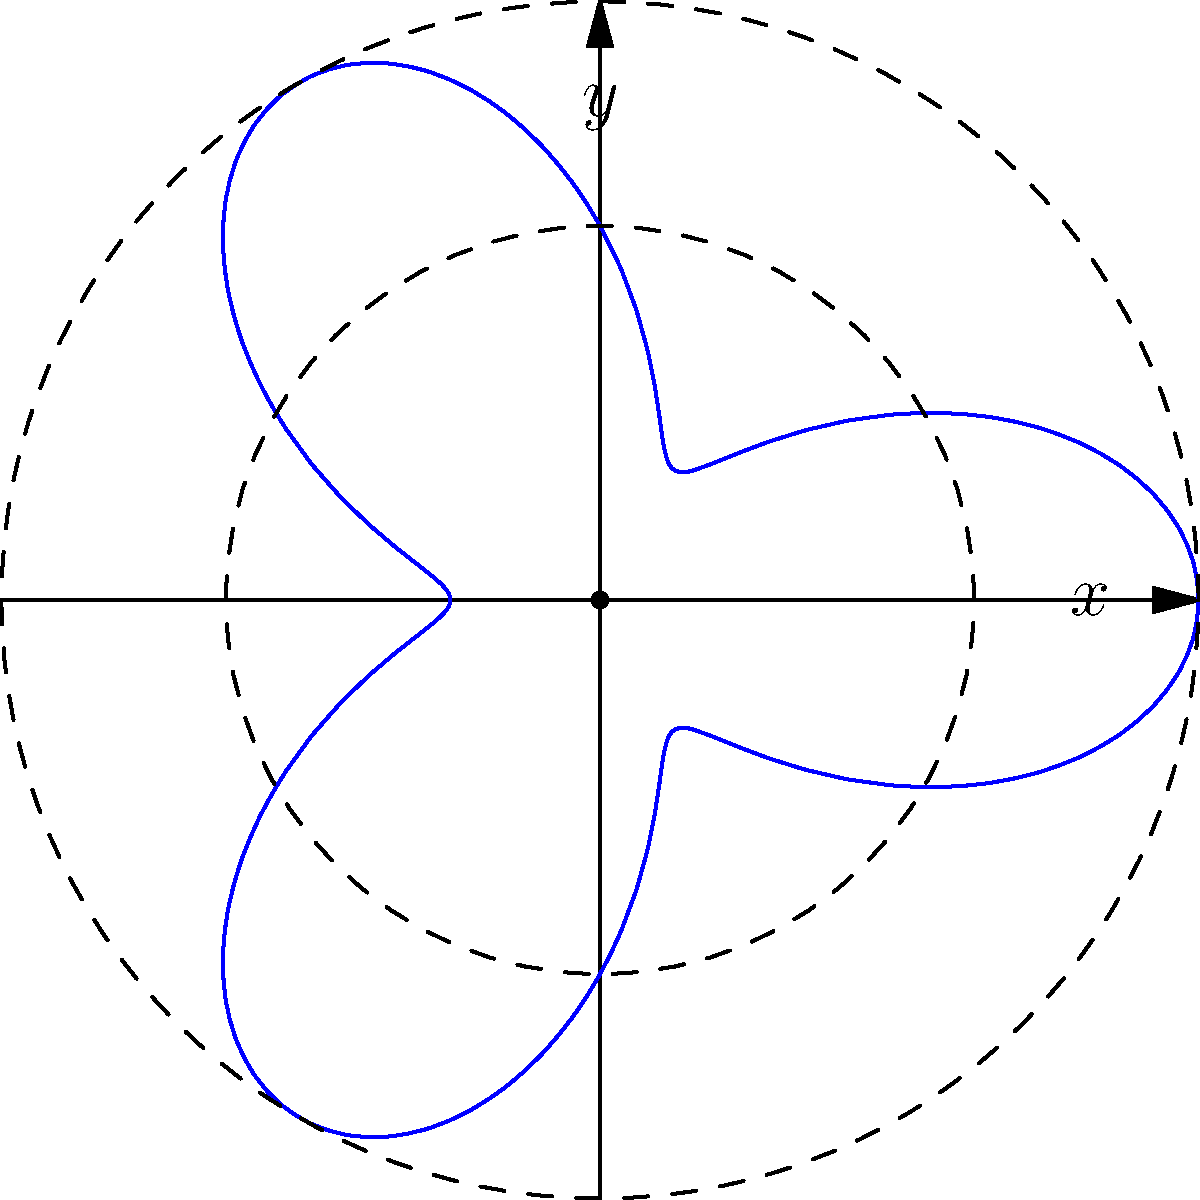As a private investigator, you're testing a new GPS tracking device. The device's range is represented by the polar equation $r = 5 + 3\cos(3\theta)$, where $r$ is in kilometers. What is the maximum range of the device? To find the maximum range of the GPS tracking device, we need to determine the maximum value of $r$ in the given polar equation:

1) The equation is $r = 5 + 3\cos(3\theta)$

2) The maximum value of cosine is 1, which occurs when its argument is a multiple of $2\pi$.

3) When $\cos(3\theta) = 1$, the equation becomes:
   $r_{max} = 5 + 3(1) = 5 + 3 = 8$

4) The minimum value of cosine is -1, which would give:
   $r_{min} = 5 + 3(-1) = 5 - 3 = 2$

5) The graph shows the curve oscillating between the circles with radii 2 and 8.

Therefore, the maximum range of the GPS tracking device is 8 kilometers.
Answer: 8 kilometers 